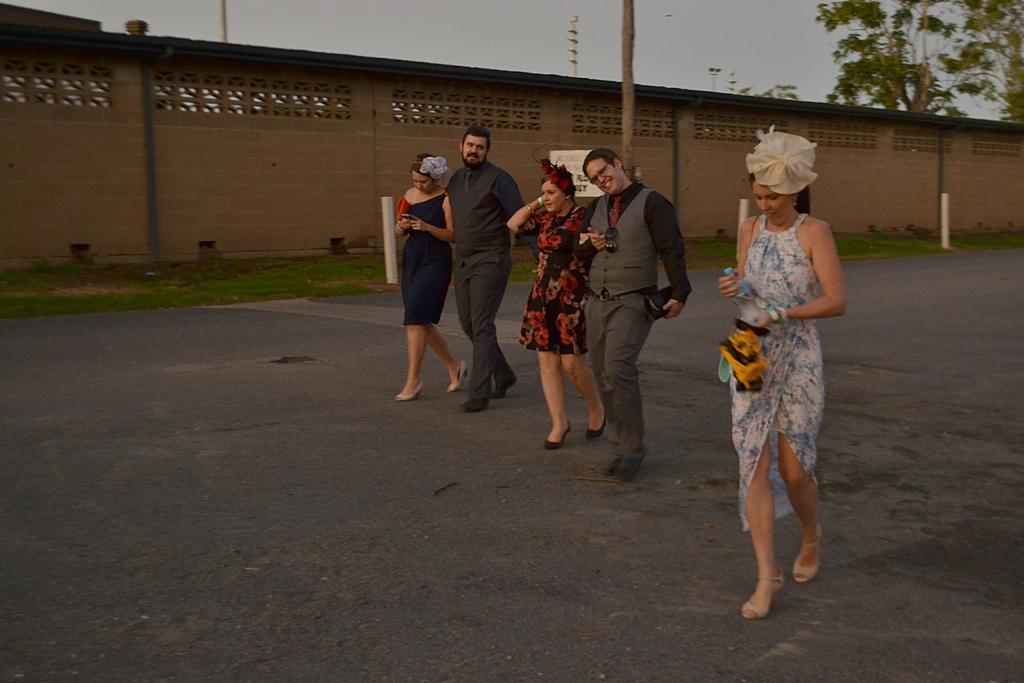Can you describe this image briefly? In this image there are five persons walking on the road. Beside them there is a wall. Behind the wall there are poles and trees. On the right side there is a woman who is holding the bottle and a bag. Beside her there are two couples. 